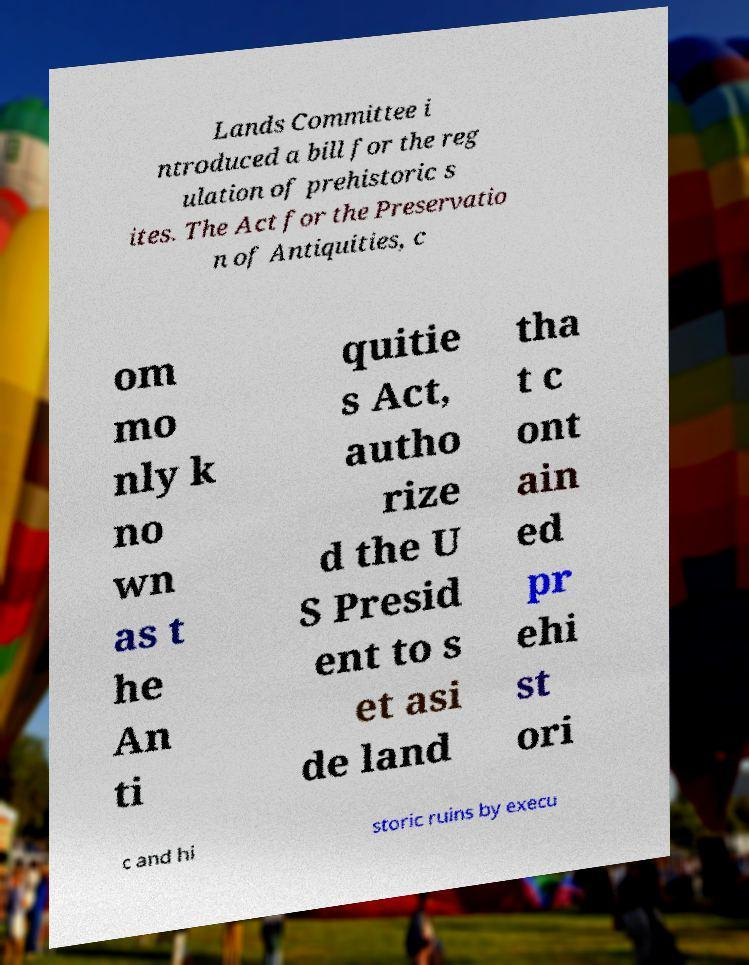Can you accurately transcribe the text from the provided image for me? Lands Committee i ntroduced a bill for the reg ulation of prehistoric s ites. The Act for the Preservatio n of Antiquities, c om mo nly k no wn as t he An ti quitie s Act, autho rize d the U S Presid ent to s et asi de land tha t c ont ain ed pr ehi st ori c and hi storic ruins by execu 